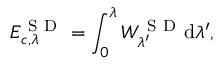<formula> <loc_0><loc_0><loc_500><loc_500>E _ { c , \lambda } ^ { S D } = \int _ { 0 } ^ { \lambda } W _ { \lambda ^ { \prime } } ^ { S D } d \lambda ^ { \prime } ,</formula> 